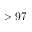<formula> <loc_0><loc_0><loc_500><loc_500>> 9 7</formula> 